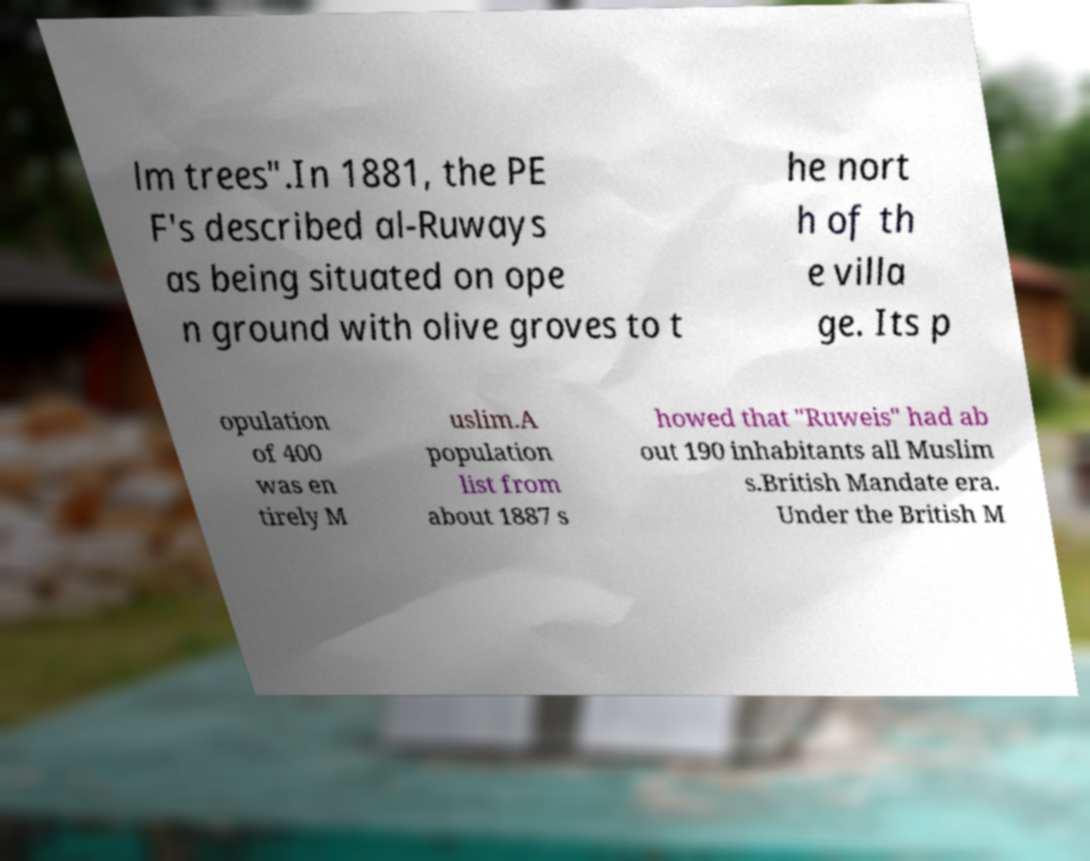There's text embedded in this image that I need extracted. Can you transcribe it verbatim? lm trees".In 1881, the PE F's described al-Ruways as being situated on ope n ground with olive groves to t he nort h of th e villa ge. Its p opulation of 400 was en tirely M uslim.A population list from about 1887 s howed that "Ruweis" had ab out 190 inhabitants all Muslim s.British Mandate era. Under the British M 